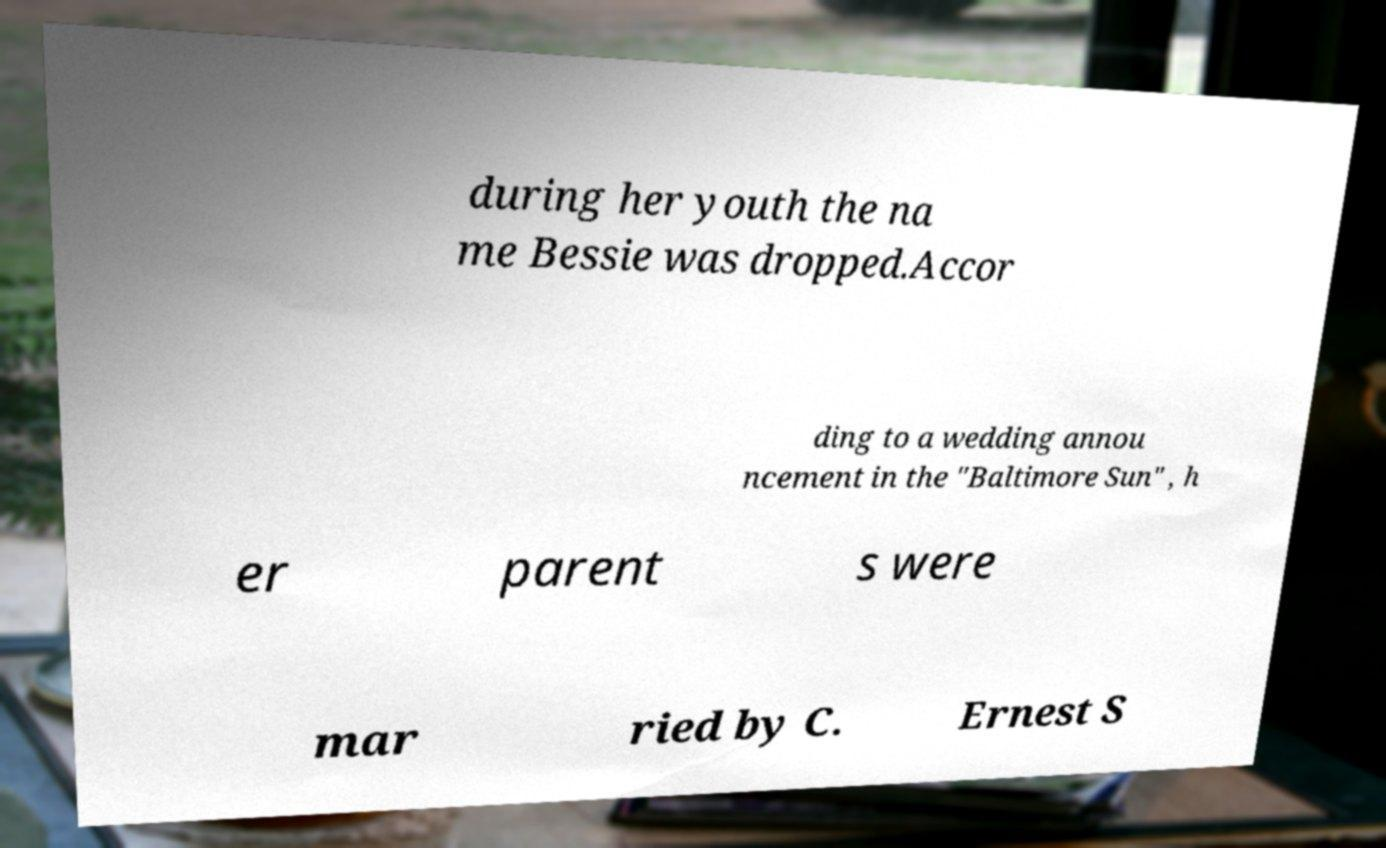Can you read and provide the text displayed in the image?This photo seems to have some interesting text. Can you extract and type it out for me? during her youth the na me Bessie was dropped.Accor ding to a wedding annou ncement in the "Baltimore Sun" , h er parent s were mar ried by C. Ernest S 